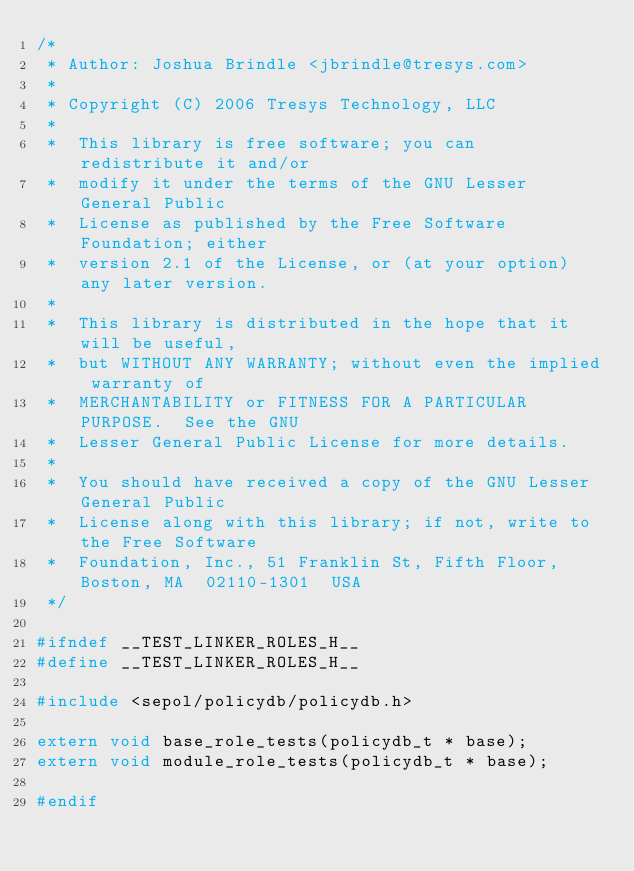<code> <loc_0><loc_0><loc_500><loc_500><_C_>/*
 * Author: Joshua Brindle <jbrindle@tresys.com>
 *
 * Copyright (C) 2006 Tresys Technology, LLC
 *
 *  This library is free software; you can redistribute it and/or
 *  modify it under the terms of the GNU Lesser General Public
 *  License as published by the Free Software Foundation; either
 *  version 2.1 of the License, or (at your option) any later version.
 *
 *  This library is distributed in the hope that it will be useful,
 *  but WITHOUT ANY WARRANTY; without even the implied warranty of
 *  MERCHANTABILITY or FITNESS FOR A PARTICULAR PURPOSE.  See the GNU
 *  Lesser General Public License for more details.
 *
 *  You should have received a copy of the GNU Lesser General Public
 *  License along with this library; if not, write to the Free Software
 *  Foundation, Inc., 51 Franklin St, Fifth Floor, Boston, MA  02110-1301  USA
 */

#ifndef __TEST_LINKER_ROLES_H__
#define __TEST_LINKER_ROLES_H__

#include <sepol/policydb/policydb.h>

extern void base_role_tests(policydb_t * base);
extern void module_role_tests(policydb_t * base);

#endif
</code> 